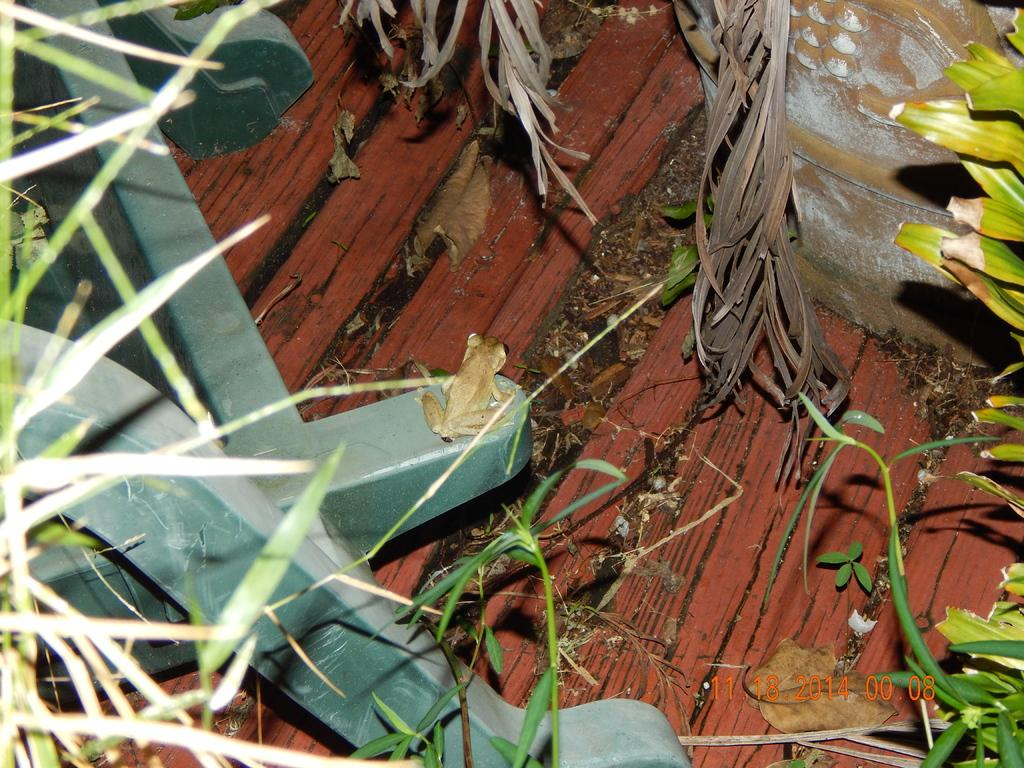What is the main subject of the image? There is a frog on a stand in the image. What else can be seen in the image besides the frog? There is a flower pot and plants visible in the image. What type of surface is visible in the background of the image? There is a wooden surface in the background of the image. What type of celery can be seen growing in the flower pot in the image? There is no celery present in the image; the flower pot contains plants. How does the frog attract attention in the image? The frog does not actively attract attention in the image; it is simply sitting on the stand. 